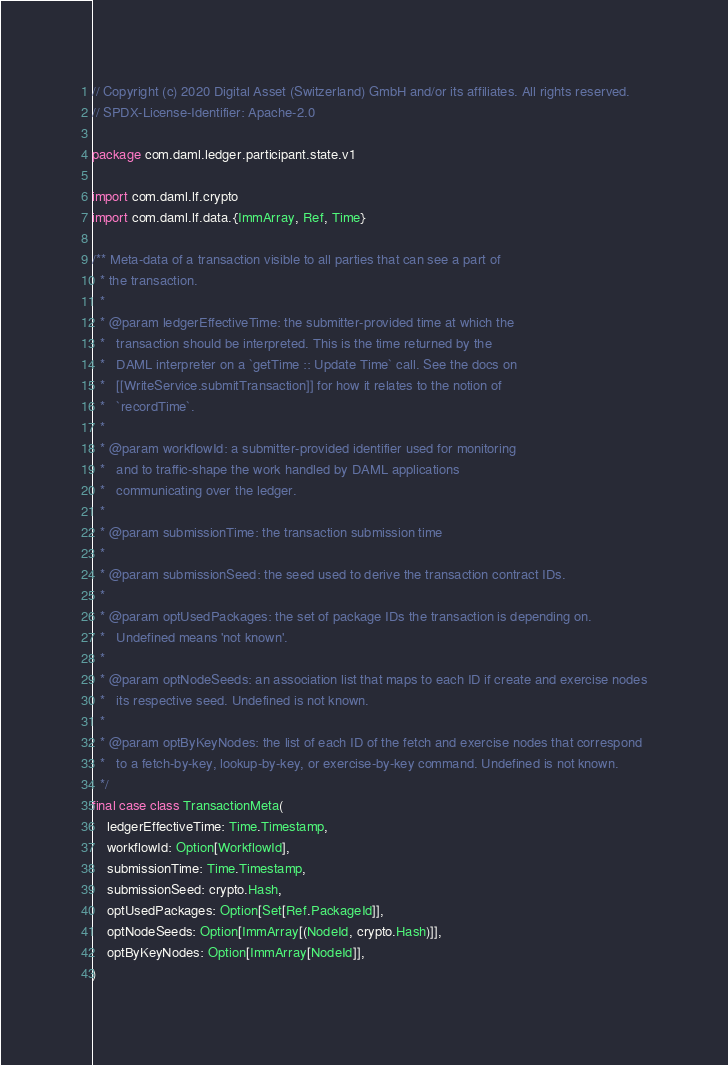<code> <loc_0><loc_0><loc_500><loc_500><_Scala_>// Copyright (c) 2020 Digital Asset (Switzerland) GmbH and/or its affiliates. All rights reserved.
// SPDX-License-Identifier: Apache-2.0

package com.daml.ledger.participant.state.v1

import com.daml.lf.crypto
import com.daml.lf.data.{ImmArray, Ref, Time}

/** Meta-data of a transaction visible to all parties that can see a part of
  * the transaction.
  *
  * @param ledgerEffectiveTime: the submitter-provided time at which the
  *   transaction should be interpreted. This is the time returned by the
  *   DAML interpreter on a `getTime :: Update Time` call. See the docs on
  *   [[WriteService.submitTransaction]] for how it relates to the notion of
  *   `recordTime`.
  *
  * @param workflowId: a submitter-provided identifier used for monitoring
  *   and to traffic-shape the work handled by DAML applications
  *   communicating over the ledger.
  *
  * @param submissionTime: the transaction submission time
  *
  * @param submissionSeed: the seed used to derive the transaction contract IDs.
  *
  * @param optUsedPackages: the set of package IDs the transaction is depending on.
  *   Undefined means 'not known'.
  *
  * @param optNodeSeeds: an association list that maps to each ID if create and exercise nodes
  *   its respective seed. Undefined is not known.
  *
  * @param optByKeyNodes: the list of each ID of the fetch and exercise nodes that correspond
  *   to a fetch-by-key, lookup-by-key, or exercise-by-key command. Undefined is not known.
  */
final case class TransactionMeta(
    ledgerEffectiveTime: Time.Timestamp,
    workflowId: Option[WorkflowId],
    submissionTime: Time.Timestamp,
    submissionSeed: crypto.Hash,
    optUsedPackages: Option[Set[Ref.PackageId]],
    optNodeSeeds: Option[ImmArray[(NodeId, crypto.Hash)]],
    optByKeyNodes: Option[ImmArray[NodeId]],
)
</code> 